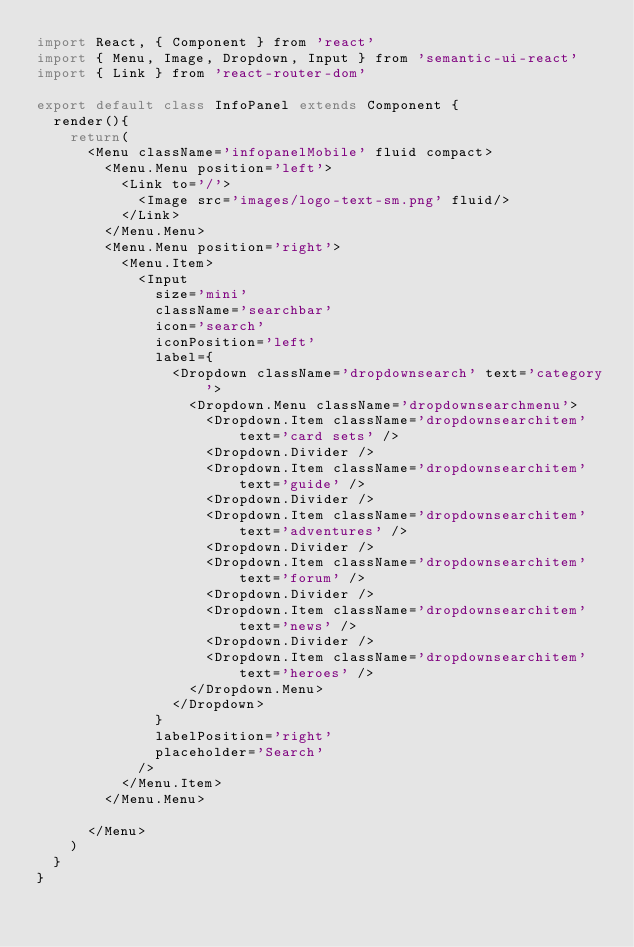Convert code to text. <code><loc_0><loc_0><loc_500><loc_500><_JavaScript_>import React, { Component } from 'react'
import { Menu, Image, Dropdown, Input } from 'semantic-ui-react'
import { Link } from 'react-router-dom'

export default class InfoPanel extends Component {
  render(){
    return(
      <Menu className='infopanelMobile' fluid compact>
        <Menu.Menu position='left'>
          <Link to='/'>
            <Image src='images/logo-text-sm.png' fluid/>
          </Link>
        </Menu.Menu>
        <Menu.Menu position='right'>
          <Menu.Item>
            <Input
              size='mini'
              className='searchbar'
              icon='search'
              iconPosition='left'
              label={
                <Dropdown className='dropdownsearch' text='category'>
                  <Dropdown.Menu className='dropdownsearchmenu'>
                    <Dropdown.Item className='dropdownsearchitem' text='card sets' />
                    <Dropdown.Divider />
                    <Dropdown.Item className='dropdownsearchitem' text='guide' />
                    <Dropdown.Divider />
                    <Dropdown.Item className='dropdownsearchitem' text='adventures' />
                    <Dropdown.Divider />
                    <Dropdown.Item className='dropdownsearchitem' text='forum' />
                    <Dropdown.Divider />
                    <Dropdown.Item className='dropdownsearchitem' text='news' />
                    <Dropdown.Divider />
                    <Dropdown.Item className='dropdownsearchitem' text='heroes' />
                  </Dropdown.Menu>
                </Dropdown>
              }
              labelPosition='right'
              placeholder='Search'
            />
          </Menu.Item>
        </Menu.Menu>

      </Menu>
    )
  }
}
</code> 